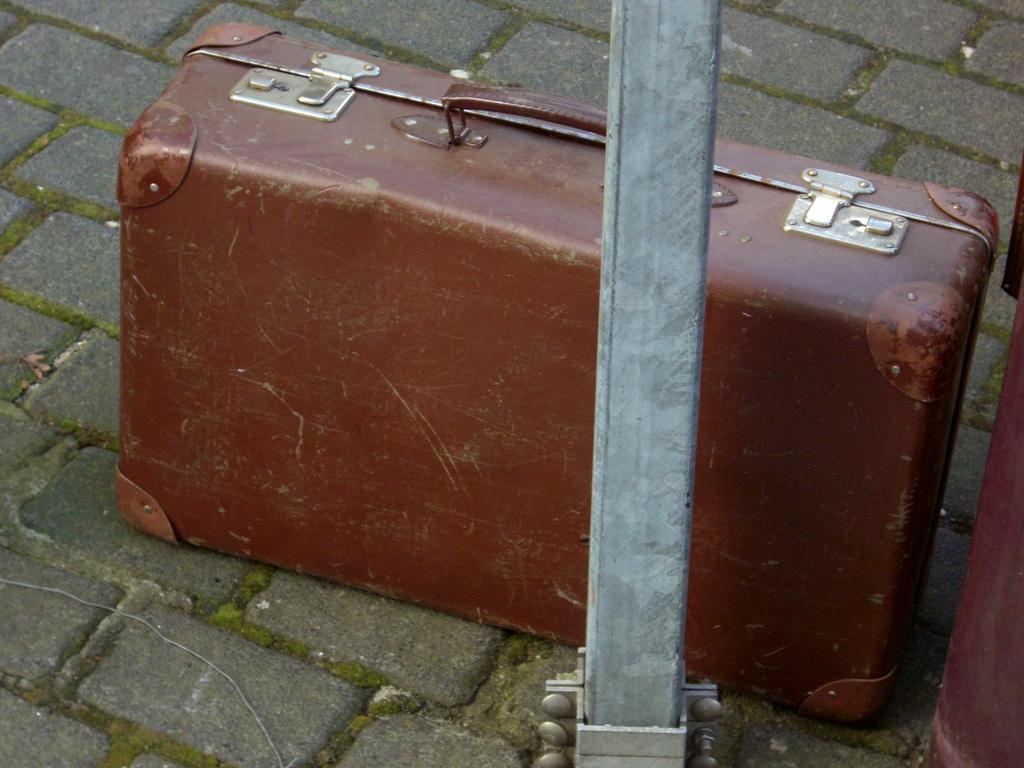What object can be seen in the image that might contain items? There is a box in the image that might contain items. What other object is present in the image that can hold something? There is a holder in the image that can hold something. What architectural feature is visible in the image? There is a pillar in the image. What surface is visible in the image? The floor is visible in the image. What type of song is being played in the background of the image? There is no information about any song being played in the image. --- 